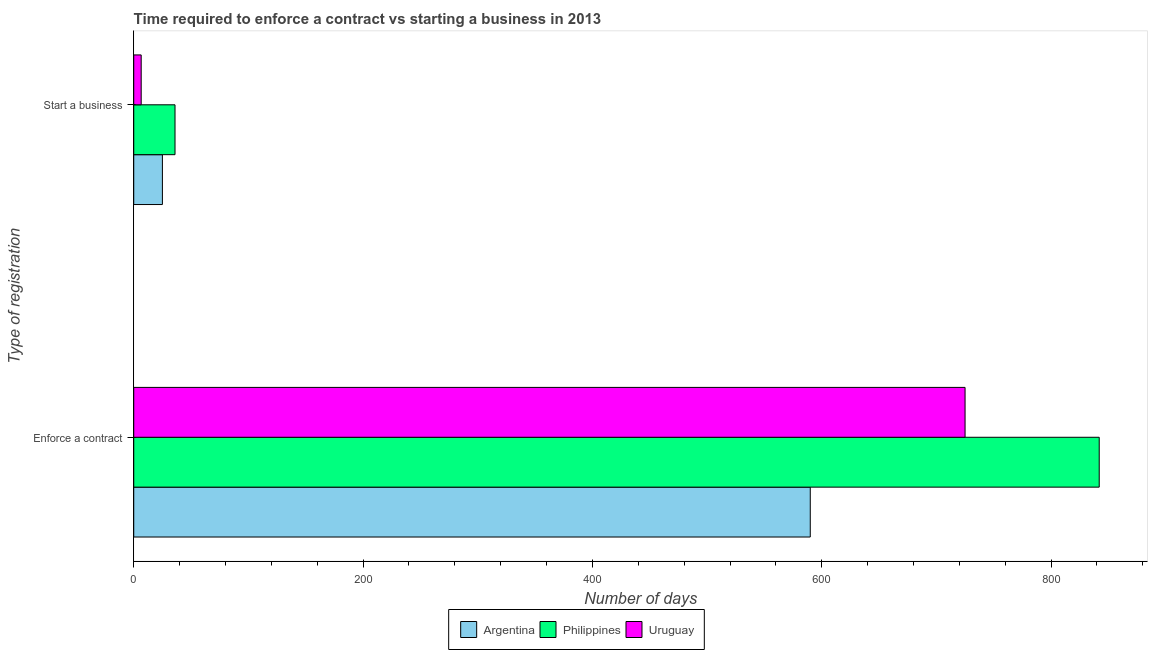How many different coloured bars are there?
Provide a short and direct response. 3. Are the number of bars per tick equal to the number of legend labels?
Give a very brief answer. Yes. How many bars are there on the 2nd tick from the bottom?
Your answer should be very brief. 3. What is the label of the 2nd group of bars from the top?
Ensure brevity in your answer.  Enforce a contract. Across all countries, what is the maximum number of days to enforece a contract?
Keep it short and to the point. 842. Across all countries, what is the minimum number of days to start a business?
Ensure brevity in your answer.  6.5. In which country was the number of days to start a business minimum?
Your response must be concise. Uruguay. What is the total number of days to enforece a contract in the graph?
Keep it short and to the point. 2157. What is the difference between the number of days to start a business in Uruguay and that in Philippines?
Give a very brief answer. -29.5. What is the difference between the number of days to enforece a contract in Uruguay and the number of days to start a business in Argentina?
Provide a succinct answer. 700. What is the average number of days to enforece a contract per country?
Give a very brief answer. 719. What is the difference between the number of days to enforece a contract and number of days to start a business in Philippines?
Give a very brief answer. 806. What is the ratio of the number of days to enforece a contract in Argentina to that in Philippines?
Keep it short and to the point. 0.7. Is the number of days to enforece a contract in Argentina less than that in Uruguay?
Ensure brevity in your answer.  Yes. In how many countries, is the number of days to start a business greater than the average number of days to start a business taken over all countries?
Keep it short and to the point. 2. What does the 2nd bar from the top in Enforce a contract represents?
Keep it short and to the point. Philippines. How many bars are there?
Your answer should be compact. 6. Are all the bars in the graph horizontal?
Offer a very short reply. Yes. How many countries are there in the graph?
Offer a terse response. 3. What is the difference between two consecutive major ticks on the X-axis?
Your answer should be compact. 200. Does the graph contain any zero values?
Give a very brief answer. No. Does the graph contain grids?
Give a very brief answer. No. How are the legend labels stacked?
Keep it short and to the point. Horizontal. What is the title of the graph?
Offer a terse response. Time required to enforce a contract vs starting a business in 2013. What is the label or title of the X-axis?
Provide a short and direct response. Number of days. What is the label or title of the Y-axis?
Provide a succinct answer. Type of registration. What is the Number of days of Argentina in Enforce a contract?
Give a very brief answer. 590. What is the Number of days in Philippines in Enforce a contract?
Keep it short and to the point. 842. What is the Number of days of Uruguay in Enforce a contract?
Make the answer very short. 725. What is the Number of days in Philippines in Start a business?
Keep it short and to the point. 36. What is the Number of days in Uruguay in Start a business?
Provide a succinct answer. 6.5. Across all Type of registration, what is the maximum Number of days in Argentina?
Keep it short and to the point. 590. Across all Type of registration, what is the maximum Number of days in Philippines?
Your response must be concise. 842. Across all Type of registration, what is the maximum Number of days of Uruguay?
Offer a terse response. 725. Across all Type of registration, what is the minimum Number of days of Argentina?
Offer a terse response. 25. Across all Type of registration, what is the minimum Number of days of Philippines?
Your answer should be very brief. 36. What is the total Number of days of Argentina in the graph?
Offer a terse response. 615. What is the total Number of days in Philippines in the graph?
Give a very brief answer. 878. What is the total Number of days in Uruguay in the graph?
Provide a short and direct response. 731.5. What is the difference between the Number of days of Argentina in Enforce a contract and that in Start a business?
Make the answer very short. 565. What is the difference between the Number of days in Philippines in Enforce a contract and that in Start a business?
Provide a short and direct response. 806. What is the difference between the Number of days in Uruguay in Enforce a contract and that in Start a business?
Ensure brevity in your answer.  718.5. What is the difference between the Number of days of Argentina in Enforce a contract and the Number of days of Philippines in Start a business?
Keep it short and to the point. 554. What is the difference between the Number of days of Argentina in Enforce a contract and the Number of days of Uruguay in Start a business?
Your answer should be very brief. 583.5. What is the difference between the Number of days of Philippines in Enforce a contract and the Number of days of Uruguay in Start a business?
Your response must be concise. 835.5. What is the average Number of days in Argentina per Type of registration?
Make the answer very short. 307.5. What is the average Number of days of Philippines per Type of registration?
Your answer should be very brief. 439. What is the average Number of days in Uruguay per Type of registration?
Offer a terse response. 365.75. What is the difference between the Number of days in Argentina and Number of days in Philippines in Enforce a contract?
Offer a terse response. -252. What is the difference between the Number of days of Argentina and Number of days of Uruguay in Enforce a contract?
Your response must be concise. -135. What is the difference between the Number of days in Philippines and Number of days in Uruguay in Enforce a contract?
Make the answer very short. 117. What is the difference between the Number of days of Philippines and Number of days of Uruguay in Start a business?
Offer a terse response. 29.5. What is the ratio of the Number of days in Argentina in Enforce a contract to that in Start a business?
Your answer should be compact. 23.6. What is the ratio of the Number of days of Philippines in Enforce a contract to that in Start a business?
Provide a short and direct response. 23.39. What is the ratio of the Number of days of Uruguay in Enforce a contract to that in Start a business?
Give a very brief answer. 111.54. What is the difference between the highest and the second highest Number of days in Argentina?
Make the answer very short. 565. What is the difference between the highest and the second highest Number of days of Philippines?
Your answer should be very brief. 806. What is the difference between the highest and the second highest Number of days of Uruguay?
Your response must be concise. 718.5. What is the difference between the highest and the lowest Number of days in Argentina?
Your answer should be compact. 565. What is the difference between the highest and the lowest Number of days of Philippines?
Provide a succinct answer. 806. What is the difference between the highest and the lowest Number of days in Uruguay?
Provide a short and direct response. 718.5. 